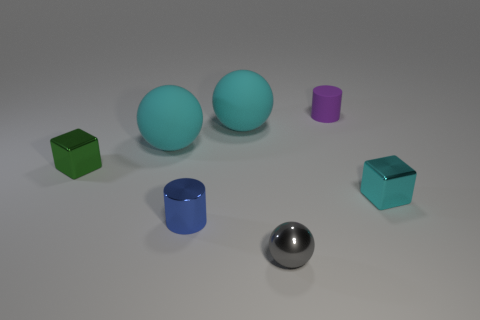Add 3 big purple shiny objects. How many objects exist? 10 Subtract all balls. How many objects are left? 4 Add 5 purple matte objects. How many purple matte objects exist? 6 Subtract 0 yellow blocks. How many objects are left? 7 Subtract all tiny blue metal objects. Subtract all large gray rubber cubes. How many objects are left? 6 Add 7 metallic cubes. How many metallic cubes are left? 9 